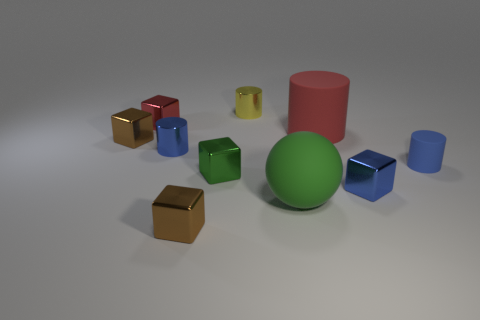Subtract all purple cylinders. How many brown cubes are left? 2 Subtract all red cylinders. How many cylinders are left? 3 Subtract 3 blocks. How many blocks are left? 2 Subtract all red blocks. How many blocks are left? 4 Subtract all cyan cylinders. Subtract all red blocks. How many cylinders are left? 4 Subtract all balls. How many objects are left? 9 Add 4 large green objects. How many large green objects exist? 5 Subtract 0 purple cylinders. How many objects are left? 10 Subtract all metal blocks. Subtract all blue rubber cylinders. How many objects are left? 4 Add 9 tiny red metal things. How many tiny red metal things are left? 10 